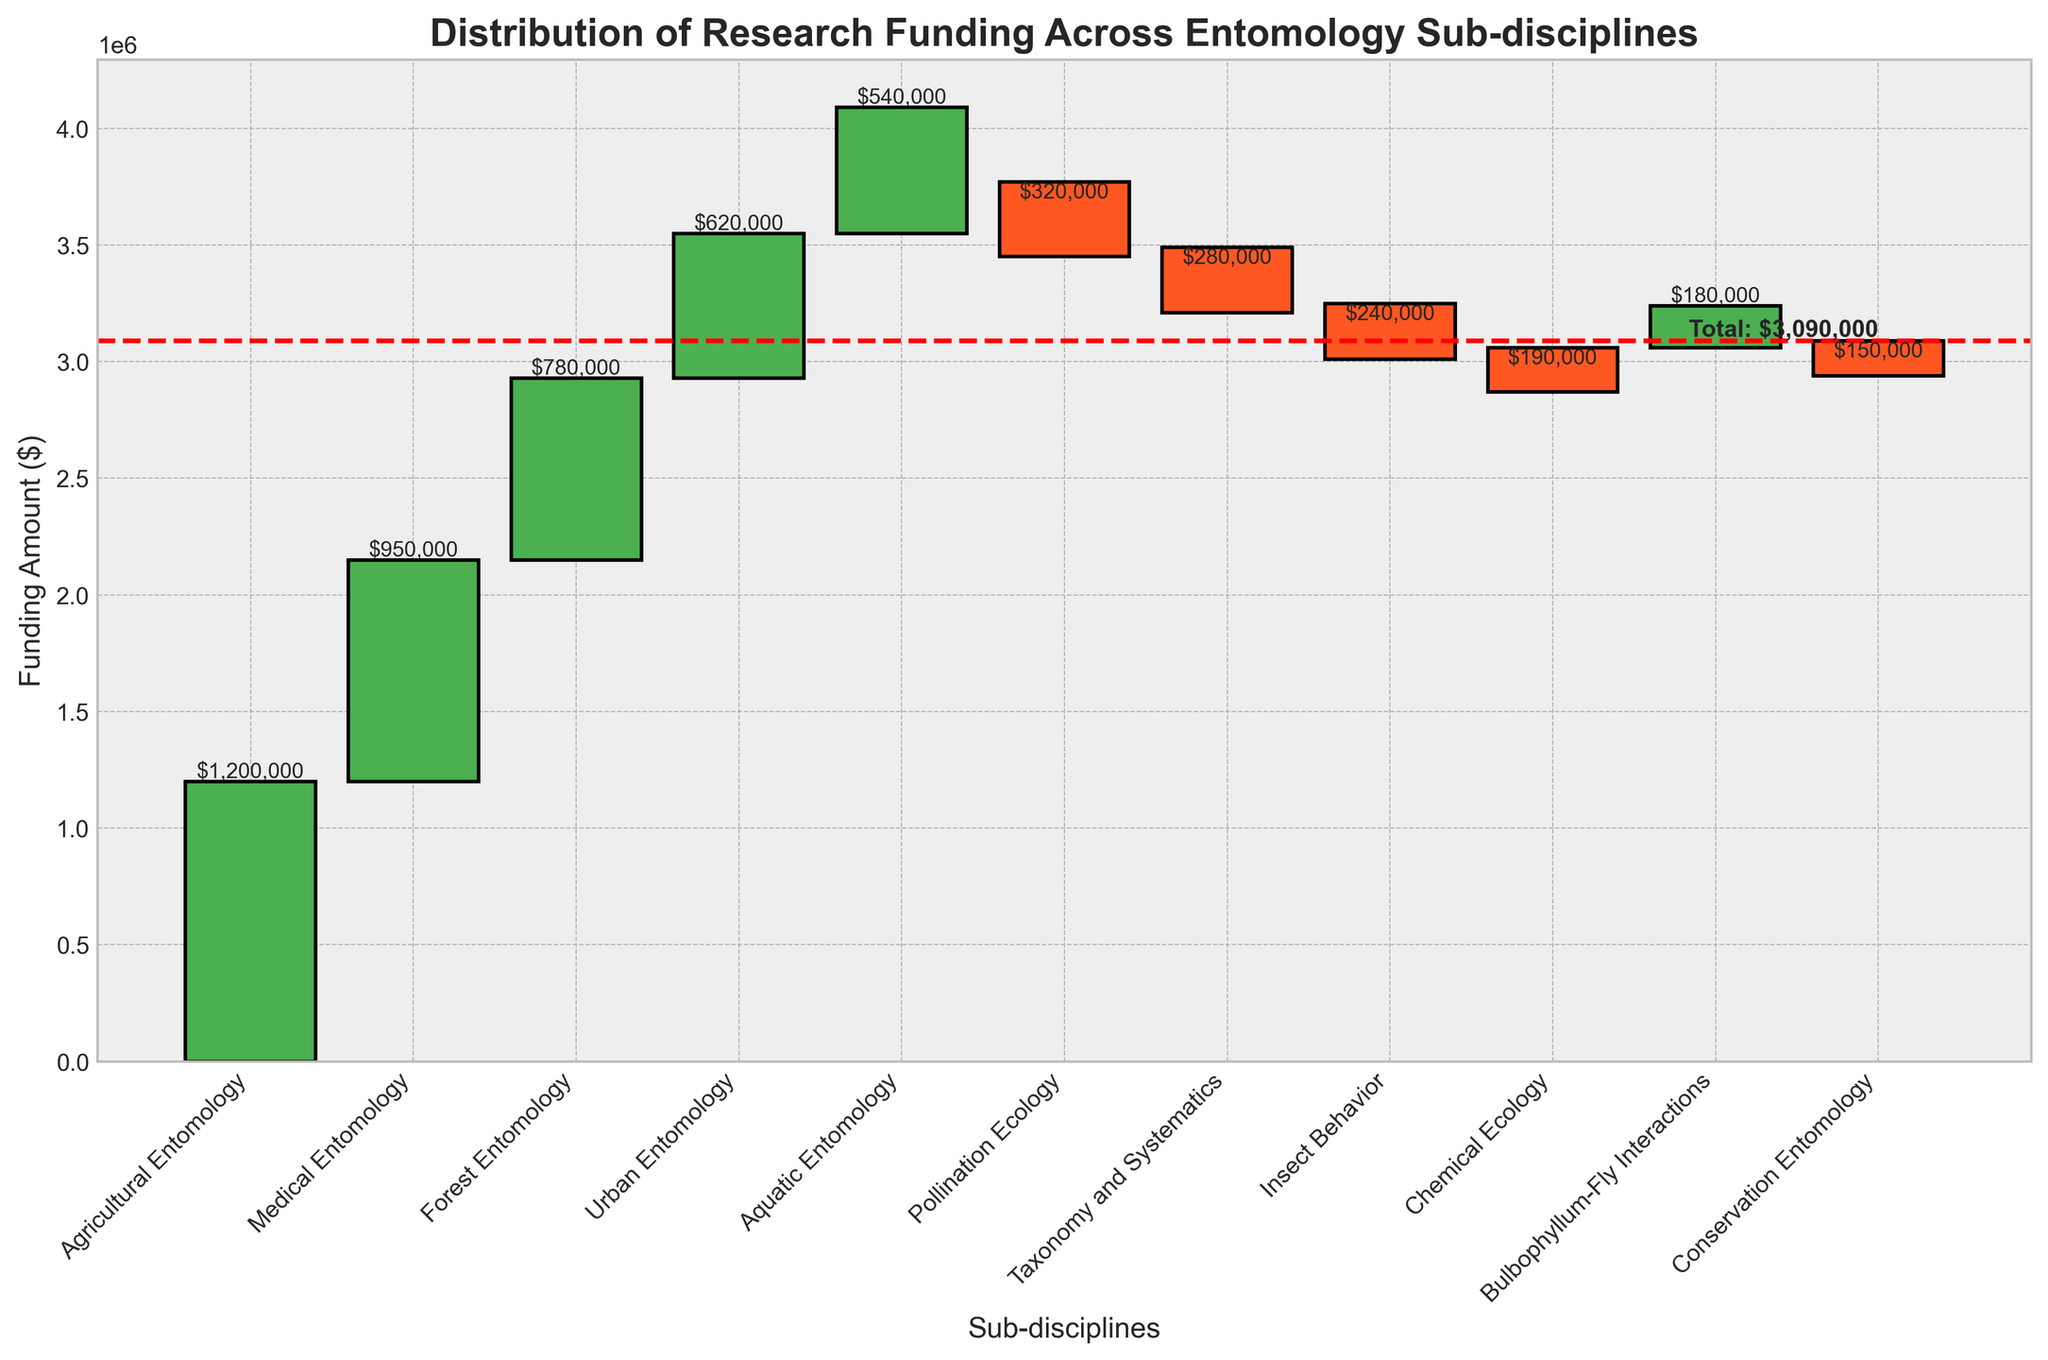What is the title of the plot? The title of the plot is at the top-center of the figure, which provides an overview of the chart's subject.
Answer: Distribution of Research Funding Across Entomology Sub-disciplines Which sub-discipline received the highest amount of funding? The sub-discipline with the tallest green bar represents the highest amount of funding.
Answer: Agricultural Entomology How much funding did Agricultural Entomology receive? The figure next to the bar for Agricultural Entomology will show the funding amount.
Answer: $1,200,000 What is the total amount of funding distributed across all sub-disciplines? The horizontal red dashed line marks the total funding amount, labeled near the rightmost part of the chart.
Answer: $3,090,000 Which sub-discipline has a negative funding value and received the least funding? The sub-discipline with the shortest and lowest red bar represents the least funding and a negative value.
Answer: Conservation Entomology What is the cumulative funding value after Urban Entomology? Add the individual funding values sequentially from the start to Urban Entomology's value.
Answer: $3,050,000 Which sub-discipline had more funding, Medical Entomology or Forest Entomology? Compare the heights of the green bars for Medical Entomology and Forest Entomology.
Answer: Medical Entomology What was the total impact on funding by negative-valued sub-disciplines? Sum the negative values: Pollination Ecology, Taxonomy and Systematics, Insect Behavior, Chemical Ecology, and Conservation Entomology.
Answer: -$1,180,000 How does the funding for Pollination Ecology compare to Bulbophyllum-Fly Interactions? Compare the heights and shading of the respective bars for both sub-disciplines, where Pollination Ecology has a negative bar and Bulbophyllum-Fly Interactions has a green bar.
Answer: Pollination Ecology has less funding What is the sum of funding for Medical Entomology and Chemical Ecology? Add the funding amounts for Medical Entomology and Chemical Ecology, referring to the value labels.
Answer: $950,000 - $190,000 = $760,000 